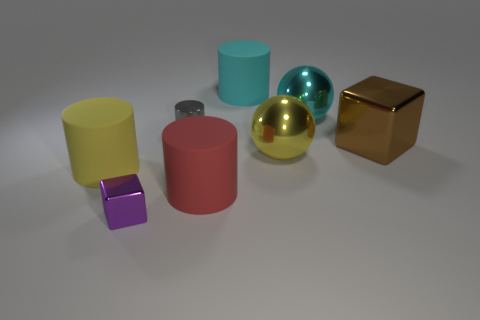Subtract all gray metallic cylinders. How many cylinders are left? 3 Subtract all gray cylinders. How many cylinders are left? 3 Add 1 large yellow metal cubes. How many objects exist? 9 Subtract all brown cylinders. Subtract all red spheres. How many cylinders are left? 4 Subtract all blocks. How many objects are left? 6 Subtract 1 red cylinders. How many objects are left? 7 Subtract all balls. Subtract all big metallic blocks. How many objects are left? 5 Add 1 cyan balls. How many cyan balls are left? 2 Add 1 tiny gray metallic objects. How many tiny gray metallic objects exist? 2 